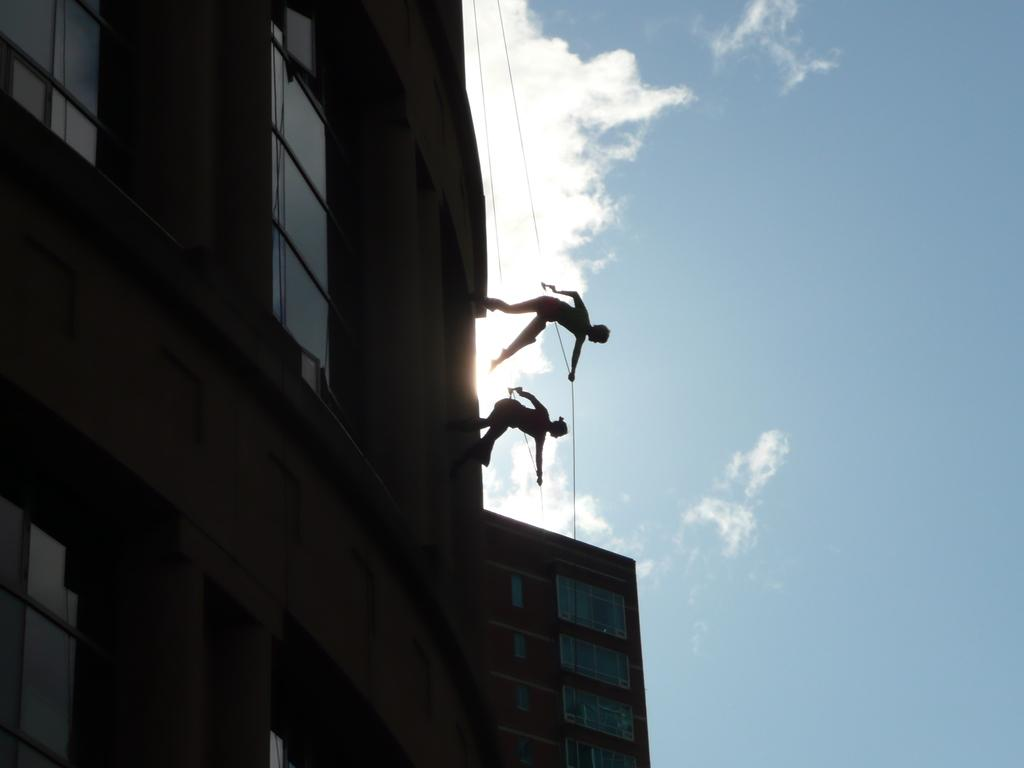Who are the two people in the image? There is a man and a woman in the image. What are they doing in the image? Both the man and woman are climbing down a building wall. How are they assisting themselves while climbing? They are using ropes for assistance. What can be seen in the background of the image? The sky is visible in the background of the image. What is the condition of the sky in the image? Clouds are present in the sky. What type of throne can be seen in the image? There is no throne present in the image; it features a man and a woman climbing down a building wall. How many toes are visible on the woman's foot in the image? There is no visible foot or toes in the image, as both the man and woman are wearing shoes and focused on climbing down the wall. 